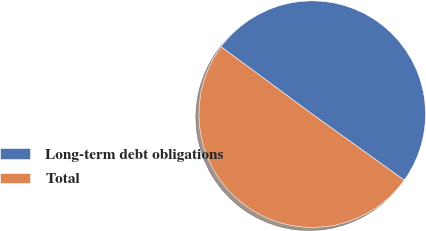Convert chart to OTSL. <chart><loc_0><loc_0><loc_500><loc_500><pie_chart><fcel>Long-term debt obligations<fcel>Total<nl><fcel>49.78%<fcel>50.22%<nl></chart> 